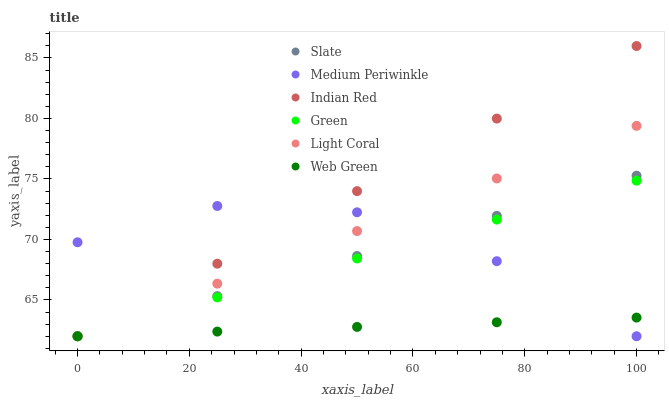Does Web Green have the minimum area under the curve?
Answer yes or no. Yes. Does Indian Red have the maximum area under the curve?
Answer yes or no. Yes. Does Medium Periwinkle have the minimum area under the curve?
Answer yes or no. No. Does Medium Periwinkle have the maximum area under the curve?
Answer yes or no. No. Is Web Green the smoothest?
Answer yes or no. Yes. Is Medium Periwinkle the roughest?
Answer yes or no. Yes. Is Medium Periwinkle the smoothest?
Answer yes or no. No. Is Web Green the roughest?
Answer yes or no. No. Does Slate have the lowest value?
Answer yes or no. Yes. Does Indian Red have the highest value?
Answer yes or no. Yes. Does Medium Periwinkle have the highest value?
Answer yes or no. No. Does Green intersect Indian Red?
Answer yes or no. Yes. Is Green less than Indian Red?
Answer yes or no. No. Is Green greater than Indian Red?
Answer yes or no. No. 